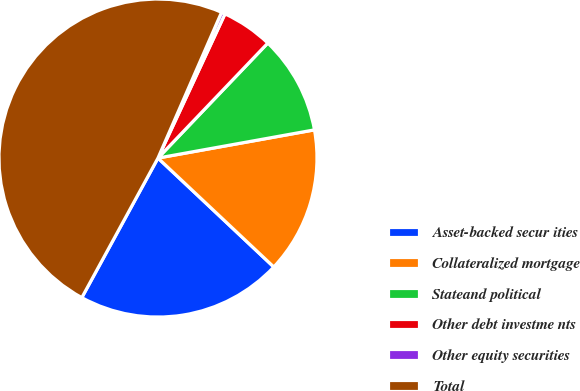Convert chart. <chart><loc_0><loc_0><loc_500><loc_500><pie_chart><fcel>Asset-backed secur ities<fcel>Collateralized mortgage<fcel>Stateand political<fcel>Other debt investme nts<fcel>Other equity securities<fcel>Total<nl><fcel>20.94%<fcel>14.85%<fcel>10.03%<fcel>5.21%<fcel>0.38%<fcel>48.6%<nl></chart> 